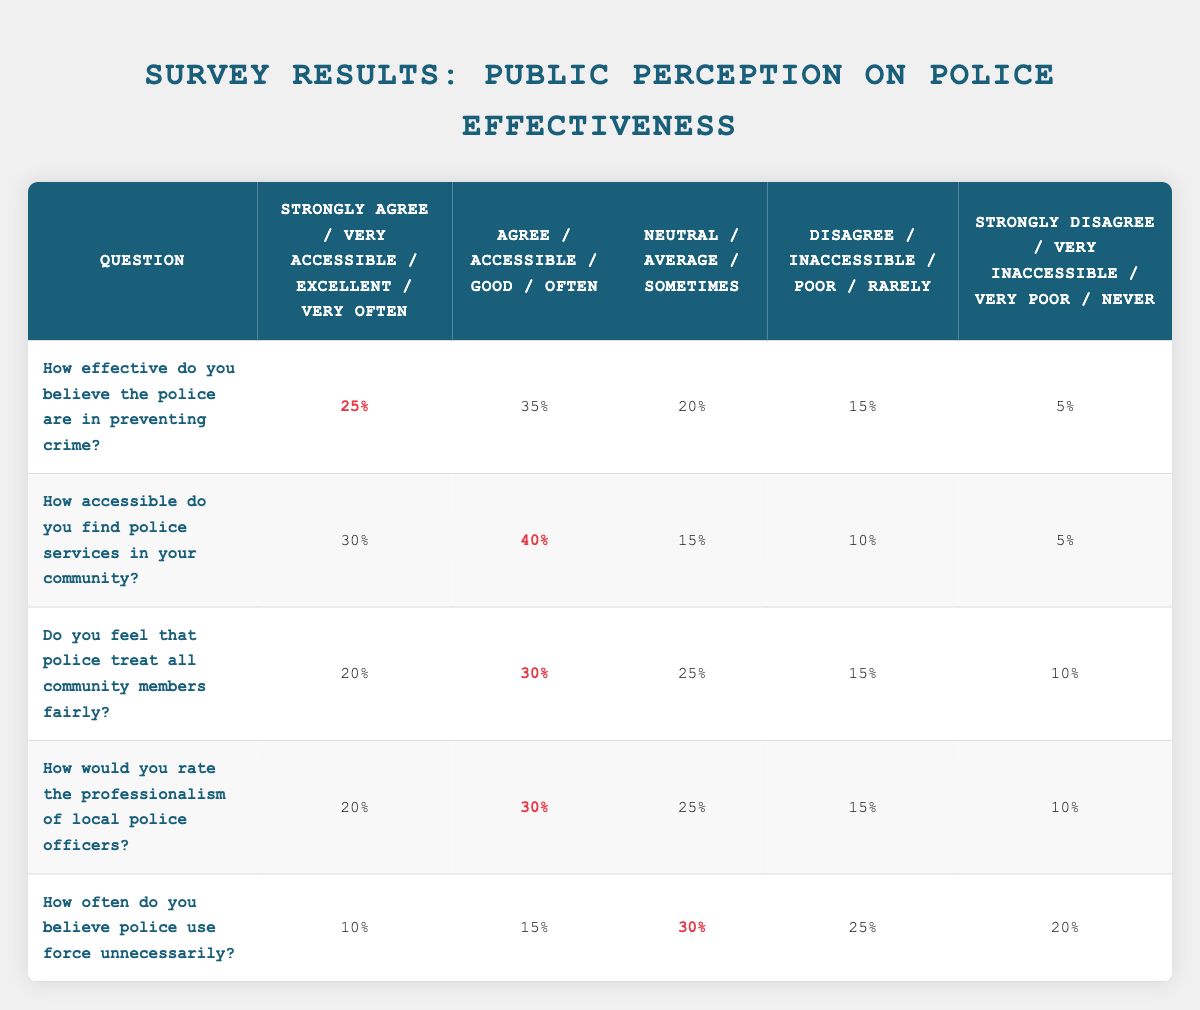How effective do you believe the police are in preventing crime? The table directly provides the responses to this question, with 25% strongly agreeing, 35% agreeing, 20% being neutral, 15% disagreeing, and 5% strongly disagreeing.
Answer: 25% What percentage of respondents feel that police treat community members fairly? The table shows that 20% strongly agree, 30% agree, 25% are neutral, 15% disagree, and 10% strongly disagree regarding fair treatment. The respondents who agree (strongly plus agree) make a total of 50%.
Answer: 50% Is the perception of police effectiveness in preventing crime higher than the perception of police accessibility? From the table, 60% (25% + 35%) believe in police effectiveness (agreeing) while 70% (30% + 40%) find police services accessible. Therefore, the perception of police accessibility is higher.
Answer: No What is the combined percentage of respondents who feel police are either effective in preventing crime or treat community members fairly? The effective perception is 25% + 35% = 60%. The fair treatment perception is 20% + 30% = 50%. Adding these together gives a total of 60% + 50% = 110%. However, we need to ensure the overlap is not counted twice, but based on yes responses it's valid to consider them as distinct. Thus, it can be presented as 110%.
Answer: 110% What percentage of respondents believe that police use force unnecessarily at least sometimes? According to the table, 10% believe police use force very often, 15% often, and 30% sometimes. Adding these percentages gives us 10% + 15% + 30% = 55%.
Answer: 55% How would you rate the professionalism of local police officers? The table indicates the ratings: 20% excellent, 30% good, 25% average, 15% poor, and 10% very poor. The rating of professionalism can be directly observed in the first column with these values, but specifically, you can state what percentage rates it as excellent.
Answer: 20% How many respondents found police services either very or somewhat accessible? By summing the percentages for "Very Accessible" (30%) and "Accessible" (40%), we find the total. Adding these gives 30% + 40% = 70%.
Answer: 70% Do the majority of respondents agree that police are effective in preventing crime? To determine this, we sum the percentages of those who strongly agree (25%) and agree (35%). This totals to 60%, which is a majority since it exceeds 50%.
Answer: Yes What is the difference in public perception between police professionalism rated as excellent versus very poor? From the table, the percentage that rated professionalism as excellent is 20%, and those rating it as very poor is 10%. The difference is 20% - 10% = 10%.
Answer: 10% How often do respondents think police use force unnecessarily compared to feeling that police are accessible? The percentage for "police use force unnecessarily" is 55% (summation above), while the percentage for those finding police services accessible is 70%. Since 55% is less than 70%, we conclude that fewer believe police use force unnecessarily when considering that they find police services accessible.
Answer: Less frequent 